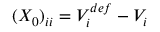<formula> <loc_0><loc_0><loc_500><loc_500>( X _ { 0 } ) _ { i i } = V _ { i } ^ { d e f } - V _ { i }</formula> 